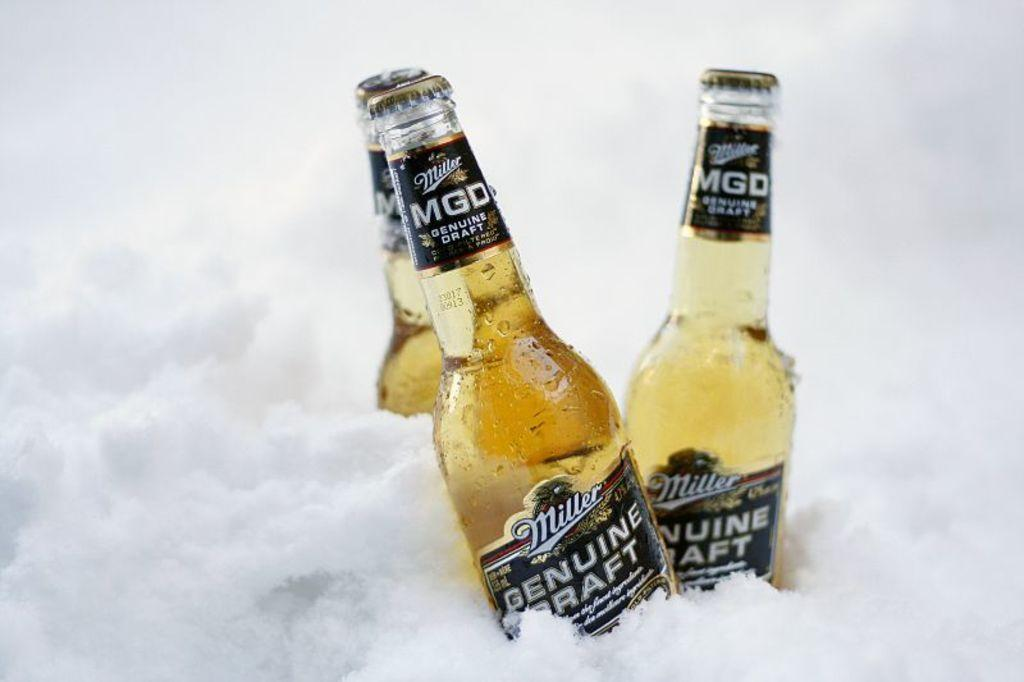<image>
Describe the image concisely. 3 bottles of miller genuine draft in the snow 